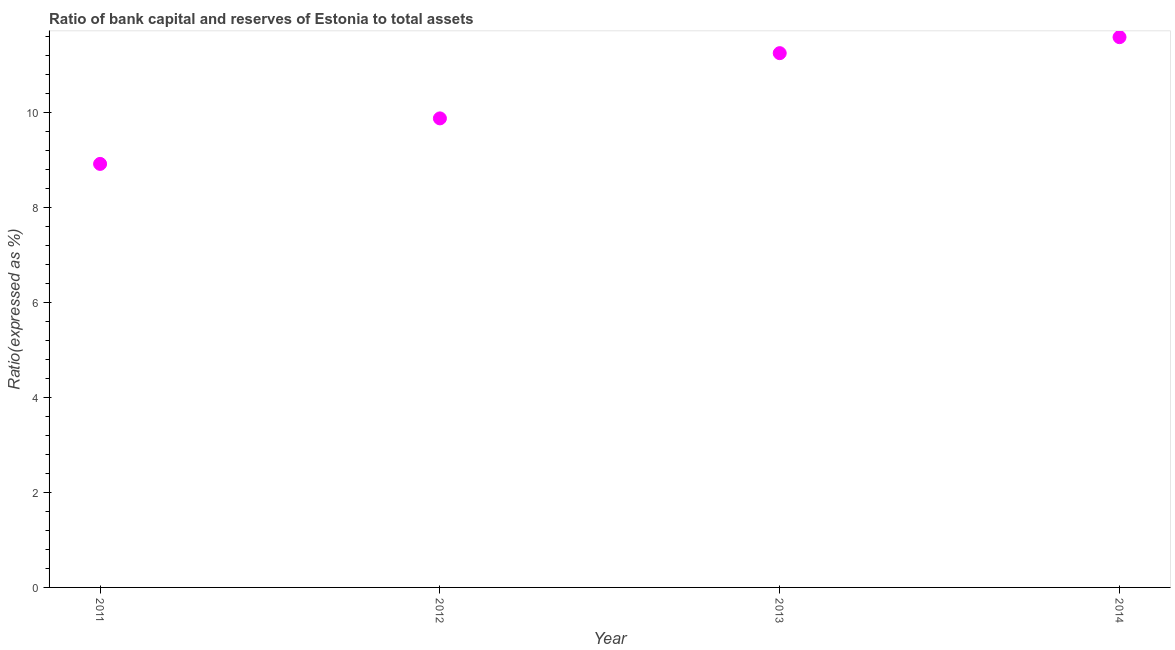What is the bank capital to assets ratio in 2011?
Ensure brevity in your answer.  8.92. Across all years, what is the maximum bank capital to assets ratio?
Keep it short and to the point. 11.6. Across all years, what is the minimum bank capital to assets ratio?
Your answer should be very brief. 8.92. In which year was the bank capital to assets ratio maximum?
Your answer should be very brief. 2014. In which year was the bank capital to assets ratio minimum?
Offer a very short reply. 2011. What is the sum of the bank capital to assets ratio?
Your answer should be very brief. 41.66. What is the difference between the bank capital to assets ratio in 2012 and 2013?
Offer a very short reply. -1.37. What is the average bank capital to assets ratio per year?
Your answer should be very brief. 10.42. What is the median bank capital to assets ratio?
Your response must be concise. 10.57. What is the ratio of the bank capital to assets ratio in 2011 to that in 2012?
Give a very brief answer. 0.9. Is the difference between the bank capital to assets ratio in 2011 and 2014 greater than the difference between any two years?
Your answer should be compact. Yes. What is the difference between the highest and the second highest bank capital to assets ratio?
Your answer should be compact. 0.34. What is the difference between the highest and the lowest bank capital to assets ratio?
Keep it short and to the point. 2.67. Does the bank capital to assets ratio monotonically increase over the years?
Your answer should be compact. Yes. How many years are there in the graph?
Keep it short and to the point. 4. What is the difference between two consecutive major ticks on the Y-axis?
Offer a terse response. 2. What is the title of the graph?
Make the answer very short. Ratio of bank capital and reserves of Estonia to total assets. What is the label or title of the Y-axis?
Your answer should be very brief. Ratio(expressed as %). What is the Ratio(expressed as %) in 2011?
Offer a very short reply. 8.92. What is the Ratio(expressed as %) in 2012?
Your response must be concise. 9.88. What is the Ratio(expressed as %) in 2013?
Your answer should be compact. 11.26. What is the Ratio(expressed as %) in 2014?
Offer a very short reply. 11.6. What is the difference between the Ratio(expressed as %) in 2011 and 2012?
Offer a very short reply. -0.96. What is the difference between the Ratio(expressed as %) in 2011 and 2013?
Offer a very short reply. -2.33. What is the difference between the Ratio(expressed as %) in 2011 and 2014?
Offer a very short reply. -2.67. What is the difference between the Ratio(expressed as %) in 2012 and 2013?
Offer a very short reply. -1.37. What is the difference between the Ratio(expressed as %) in 2012 and 2014?
Offer a very short reply. -1.71. What is the difference between the Ratio(expressed as %) in 2013 and 2014?
Keep it short and to the point. -0.34. What is the ratio of the Ratio(expressed as %) in 2011 to that in 2012?
Provide a succinct answer. 0.9. What is the ratio of the Ratio(expressed as %) in 2011 to that in 2013?
Your answer should be very brief. 0.79. What is the ratio of the Ratio(expressed as %) in 2011 to that in 2014?
Provide a succinct answer. 0.77. What is the ratio of the Ratio(expressed as %) in 2012 to that in 2013?
Give a very brief answer. 0.88. What is the ratio of the Ratio(expressed as %) in 2012 to that in 2014?
Provide a short and direct response. 0.85. 